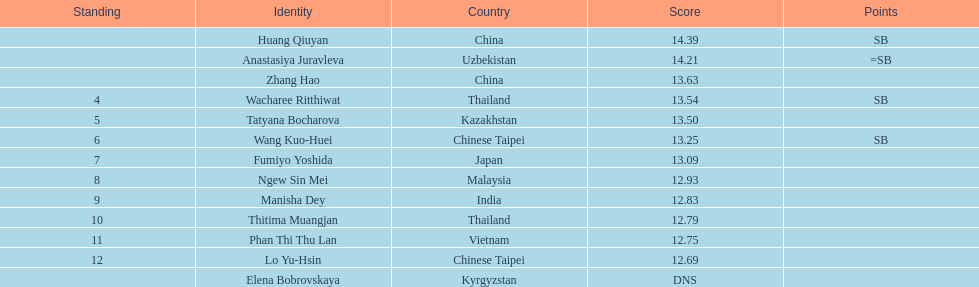How many contestants were from thailand? 2. 